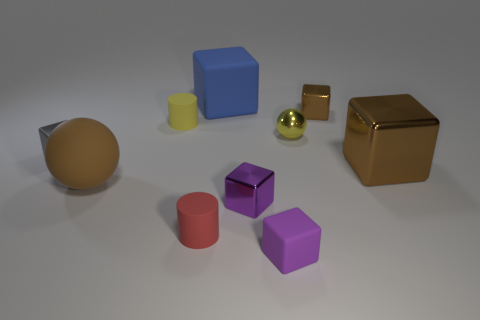Does the gray thing have the same material as the large brown thing right of the yellow cylinder?
Give a very brief answer. Yes. What color is the tiny metallic thing that is on the right side of the ball right of the large blue rubber object?
Offer a terse response. Brown. There is a matte object that is behind the brown rubber ball and in front of the tiny brown cube; what is its size?
Ensure brevity in your answer.  Small. How many other objects are the same shape as the small brown object?
Your answer should be very brief. 5. There is a tiny gray thing; is its shape the same as the small yellow thing that is on the right side of the small yellow cylinder?
Give a very brief answer. No. There is a large metal block; what number of balls are in front of it?
Offer a terse response. 1. Is there any other thing that has the same material as the red cylinder?
Your response must be concise. Yes. Does the tiny yellow thing to the left of the purple rubber thing have the same shape as the tiny red object?
Make the answer very short. Yes. What is the color of the tiny rubber object on the left side of the red rubber cylinder?
Ensure brevity in your answer.  Yellow. There is a yellow thing that is made of the same material as the blue block; what is its shape?
Keep it short and to the point. Cylinder. 